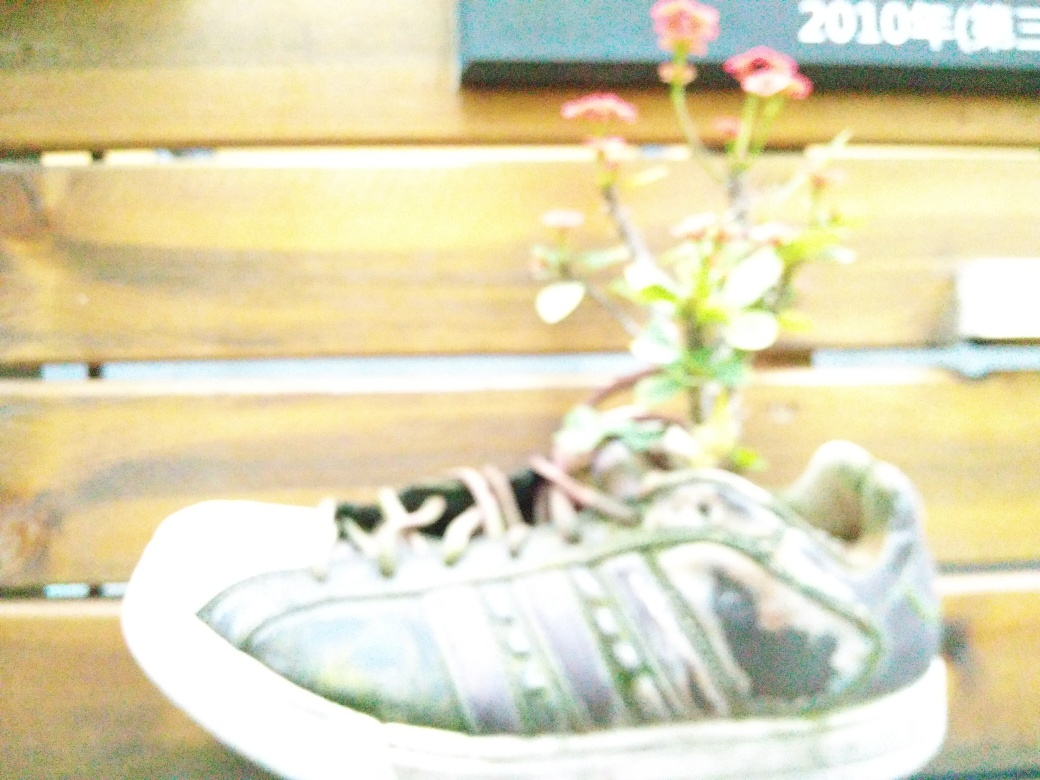How common is it to use shoes as plant pots, and what does it say about recycling and creativity? Using shoes as plant pots is a whimsical and creative form of upcycling, which is not very common but has gained popularity in certain eco-friendly and artistic communities. It showcases a resourceful approach to recycling, transforming an item that has outlived its original purpose into something new and functional, while also making a statement about sustainability and imagination in everyday life. 